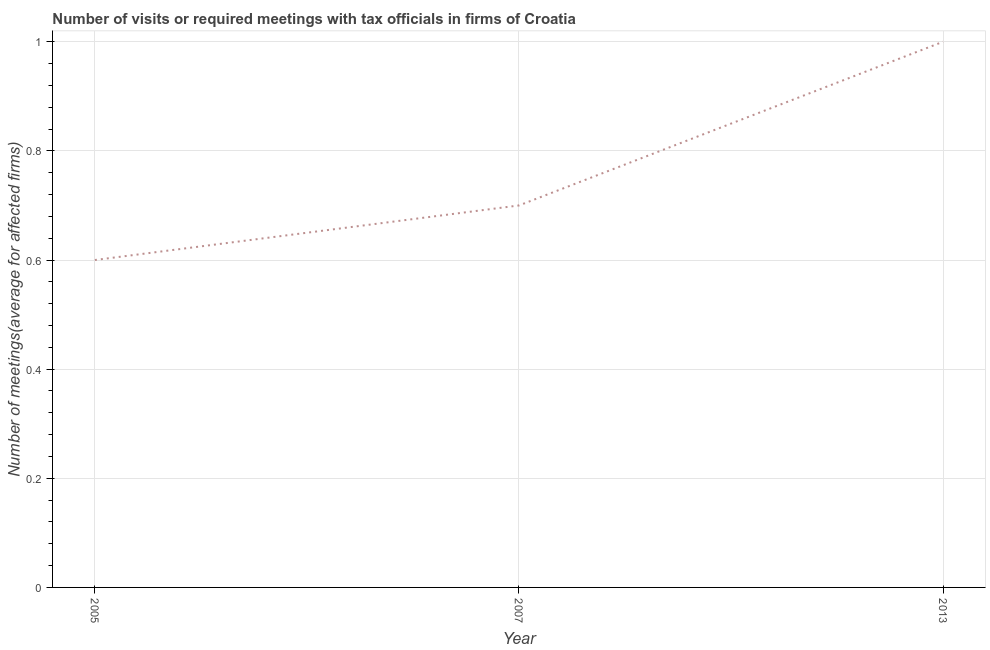In which year was the number of required meetings with tax officials minimum?
Provide a short and direct response. 2005. What is the difference between the number of required meetings with tax officials in 2007 and 2013?
Your answer should be very brief. -0.3. What is the average number of required meetings with tax officials per year?
Offer a very short reply. 0.77. What is the median number of required meetings with tax officials?
Keep it short and to the point. 0.7. Do a majority of the years between 2005 and 2007 (inclusive) have number of required meetings with tax officials greater than 0.36 ?
Offer a very short reply. Yes. What is the difference between the highest and the second highest number of required meetings with tax officials?
Keep it short and to the point. 0.3. What is the difference between the highest and the lowest number of required meetings with tax officials?
Provide a succinct answer. 0.4. How many lines are there?
Ensure brevity in your answer.  1. How many years are there in the graph?
Ensure brevity in your answer.  3. Does the graph contain any zero values?
Offer a very short reply. No. What is the title of the graph?
Offer a terse response. Number of visits or required meetings with tax officials in firms of Croatia. What is the label or title of the Y-axis?
Keep it short and to the point. Number of meetings(average for affected firms). What is the Number of meetings(average for affected firms) in 2005?
Offer a terse response. 0.6. What is the difference between the Number of meetings(average for affected firms) in 2005 and 2007?
Your answer should be very brief. -0.1. What is the difference between the Number of meetings(average for affected firms) in 2005 and 2013?
Keep it short and to the point. -0.4. What is the difference between the Number of meetings(average for affected firms) in 2007 and 2013?
Your response must be concise. -0.3. What is the ratio of the Number of meetings(average for affected firms) in 2005 to that in 2007?
Make the answer very short. 0.86. What is the ratio of the Number of meetings(average for affected firms) in 2005 to that in 2013?
Ensure brevity in your answer.  0.6. 